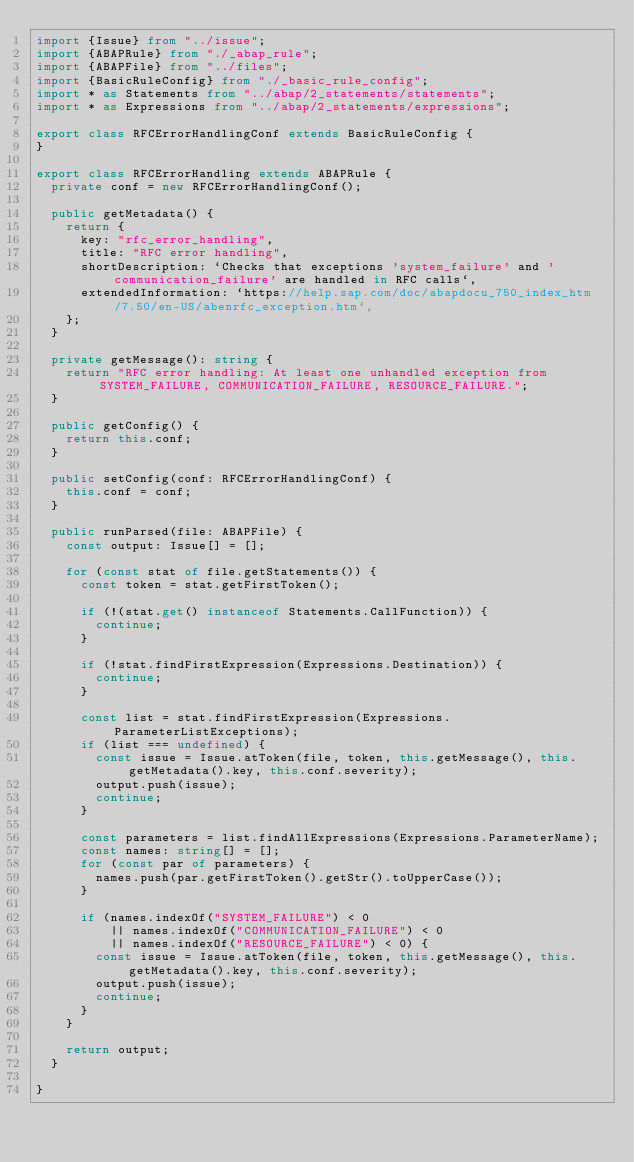Convert code to text. <code><loc_0><loc_0><loc_500><loc_500><_TypeScript_>import {Issue} from "../issue";
import {ABAPRule} from "./_abap_rule";
import {ABAPFile} from "../files";
import {BasicRuleConfig} from "./_basic_rule_config";
import * as Statements from "../abap/2_statements/statements";
import * as Expressions from "../abap/2_statements/expressions";

export class RFCErrorHandlingConf extends BasicRuleConfig {
}

export class RFCErrorHandling extends ABAPRule {
  private conf = new RFCErrorHandlingConf();

  public getMetadata() {
    return {
      key: "rfc_error_handling",
      title: "RFC error handling",
      shortDescription: `Checks that exceptions 'system_failure' and 'communication_failure' are handled in RFC calls`,
      extendedInformation: `https://help.sap.com/doc/abapdocu_750_index_htm/7.50/en-US/abenrfc_exception.htm`,
    };
  }

  private getMessage(): string {
    return "RFC error handling: At least one unhandled exception from SYSTEM_FAILURE, COMMUNICATION_FAILURE, RESOURCE_FAILURE.";
  }

  public getConfig() {
    return this.conf;
  }

  public setConfig(conf: RFCErrorHandlingConf) {
    this.conf = conf;
  }

  public runParsed(file: ABAPFile) {
    const output: Issue[] = [];

    for (const stat of file.getStatements()) {
      const token = stat.getFirstToken();

      if (!(stat.get() instanceof Statements.CallFunction)) {
        continue;
      }

      if (!stat.findFirstExpression(Expressions.Destination)) {
        continue;
      }

      const list = stat.findFirstExpression(Expressions.ParameterListExceptions);
      if (list === undefined) {
        const issue = Issue.atToken(file, token, this.getMessage(), this.getMetadata().key, this.conf.severity);
        output.push(issue);
        continue;
      }

      const parameters = list.findAllExpressions(Expressions.ParameterName);
      const names: string[] = [];
      for (const par of parameters) {
        names.push(par.getFirstToken().getStr().toUpperCase());
      }

      if (names.indexOf("SYSTEM_FAILURE") < 0
          || names.indexOf("COMMUNICATION_FAILURE") < 0
          || names.indexOf("RESOURCE_FAILURE") < 0) {
        const issue = Issue.atToken(file, token, this.getMessage(), this.getMetadata().key, this.conf.severity);
        output.push(issue);
        continue;
      }
    }

    return output;
  }

}</code> 